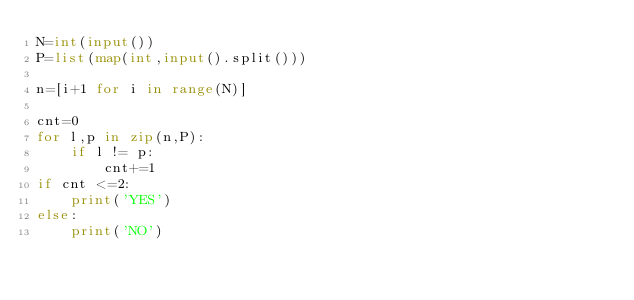Convert code to text. <code><loc_0><loc_0><loc_500><loc_500><_Python_>N=int(input())
P=list(map(int,input().split()))

n=[i+1 for i in range(N)]

cnt=0
for l,p in zip(n,P):
    if l != p:
        cnt+=1
if cnt <=2:
    print('YES')
else:
    print('NO')

</code> 